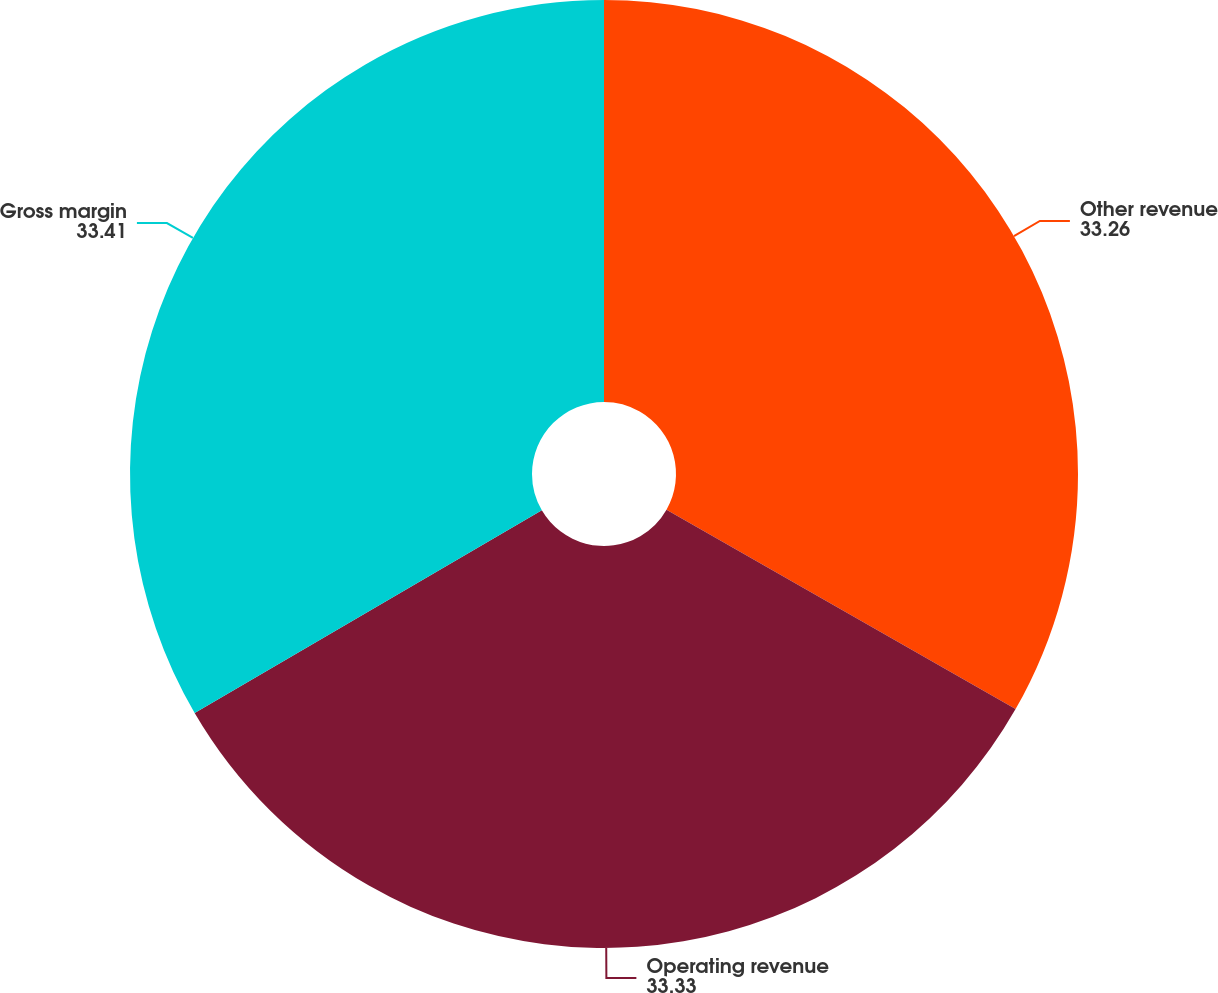Convert chart. <chart><loc_0><loc_0><loc_500><loc_500><pie_chart><fcel>Other revenue<fcel>Operating revenue<fcel>Gross margin<nl><fcel>33.26%<fcel>33.33%<fcel>33.41%<nl></chart> 